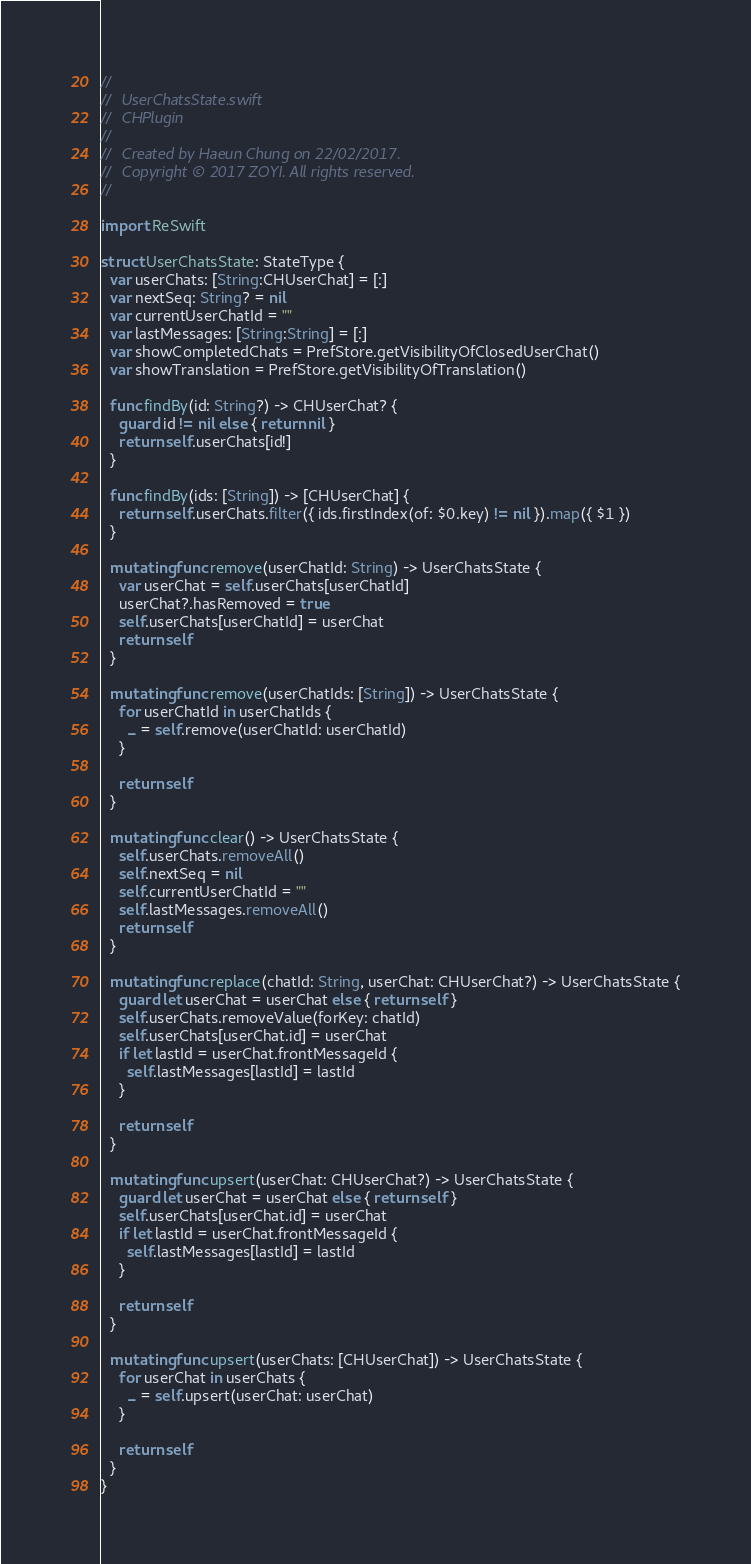<code> <loc_0><loc_0><loc_500><loc_500><_Swift_>//
//  UserChatsState.swift
//  CHPlugin
//
//  Created by Haeun Chung on 22/02/2017.
//  Copyright © 2017 ZOYI. All rights reserved.
//

import ReSwift

struct UserChatsState: StateType {
  var userChats: [String:CHUserChat] = [:]
  var nextSeq: String? = nil
  var currentUserChatId = ""
  var lastMessages: [String:String] = [:]
  var showCompletedChats = PrefStore.getVisibilityOfClosedUserChat()
  var showTranslation = PrefStore.getVisibilityOfTranslation()
  
  func findBy(id: String?) -> CHUserChat? {
    guard id != nil else { return nil }
    return self.userChats[id!]
  }
  
  func findBy(ids: [String]) -> [CHUserChat] {
    return self.userChats.filter({ ids.firstIndex(of: $0.key) != nil }).map({ $1 })
  }
  
  mutating func remove(userChatId: String) -> UserChatsState {
    var userChat = self.userChats[userChatId]
    userChat?.hasRemoved = true
    self.userChats[userChatId] = userChat
    return self
  }
  
  mutating func remove(userChatIds: [String]) -> UserChatsState {
    for userChatId in userChatIds {
      _ = self.remove(userChatId: userChatId)
    }
    
    return self
  }
  
  mutating func clear() -> UserChatsState {
    self.userChats.removeAll()
    self.nextSeq = nil
    self.currentUserChatId = ""
    self.lastMessages.removeAll()
    return self
  }
  
  mutating func replace(chatId: String, userChat: CHUserChat?) -> UserChatsState {
    guard let userChat = userChat else { return self }
    self.userChats.removeValue(forKey: chatId)
    self.userChats[userChat.id] = userChat
    if let lastId = userChat.frontMessageId {
      self.lastMessages[lastId] = lastId
    }
    
    return self
  }
  
  mutating func upsert(userChat: CHUserChat?) -> UserChatsState {
    guard let userChat = userChat else { return self }
    self.userChats[userChat.id] = userChat
    if let lastId = userChat.frontMessageId {
      self.lastMessages[lastId] = lastId
    }
    
    return self
  }
  
  mutating func upsert(userChats: [CHUserChat]) -> UserChatsState {
    for userChat in userChats {
      _ = self.upsert(userChat: userChat)
    }
    
    return self
  }
}
</code> 